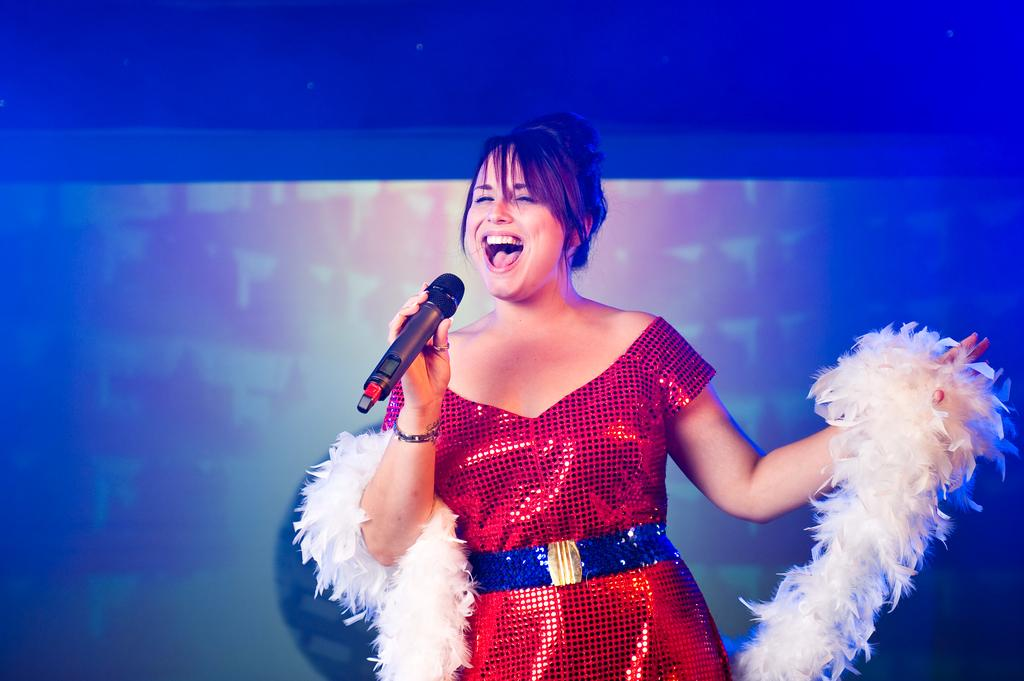Who is the main subject in the image? There is a woman in the image. What is the woman doing in the image? The woman is standing and singing. What object is present in the image that might be related to the woman's activity? There is a microphone in the image. What type of fuel is the woman using to power her performance in the image? There is no mention of fuel in the image, and the woman's performance is not related to any type of fuel. 